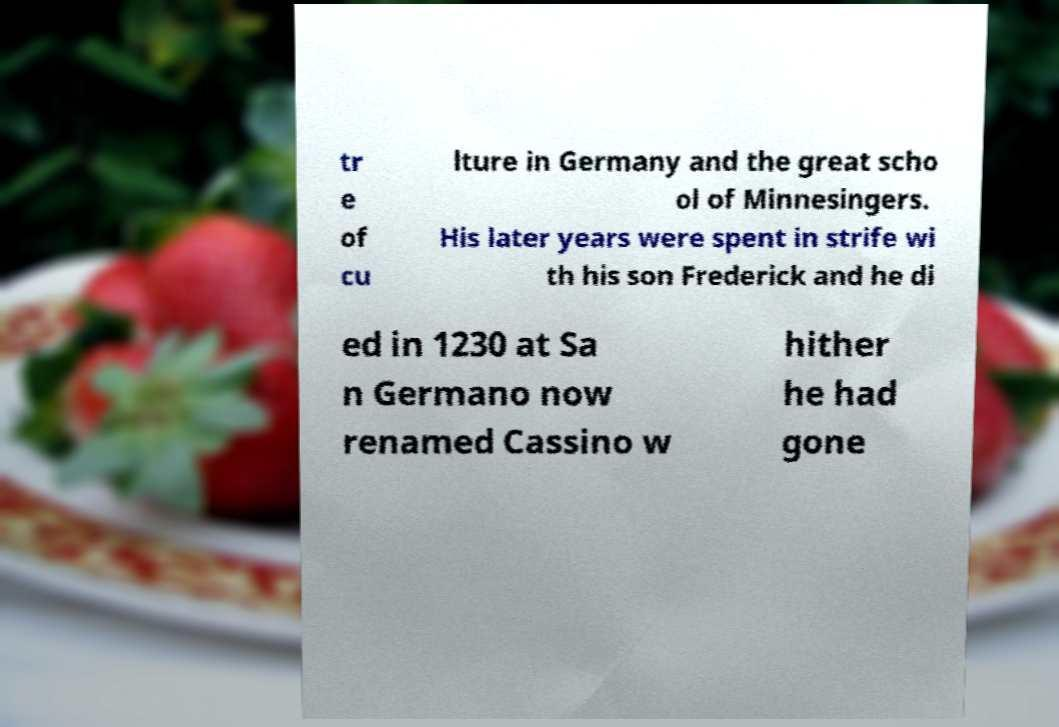Please identify and transcribe the text found in this image. tr e of cu lture in Germany and the great scho ol of Minnesingers. His later years were spent in strife wi th his son Frederick and he di ed in 1230 at Sa n Germano now renamed Cassino w hither he had gone 